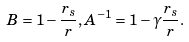Convert formula to latex. <formula><loc_0><loc_0><loc_500><loc_500>B = 1 - \frac { r _ { s } } { r } , A ^ { - 1 } = 1 - \gamma \frac { r _ { s } } { r } .</formula> 